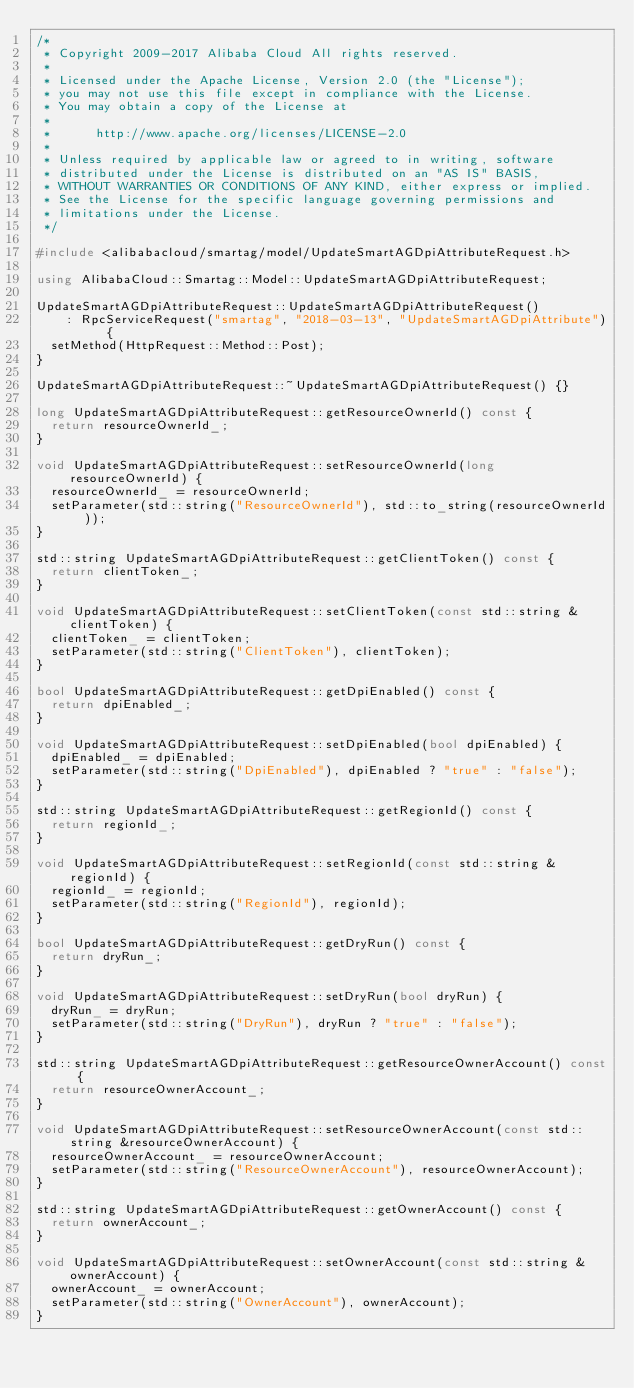Convert code to text. <code><loc_0><loc_0><loc_500><loc_500><_C++_>/*
 * Copyright 2009-2017 Alibaba Cloud All rights reserved.
 *
 * Licensed under the Apache License, Version 2.0 (the "License");
 * you may not use this file except in compliance with the License.
 * You may obtain a copy of the License at
 *
 *      http://www.apache.org/licenses/LICENSE-2.0
 *
 * Unless required by applicable law or agreed to in writing, software
 * distributed under the License is distributed on an "AS IS" BASIS,
 * WITHOUT WARRANTIES OR CONDITIONS OF ANY KIND, either express or implied.
 * See the License for the specific language governing permissions and
 * limitations under the License.
 */

#include <alibabacloud/smartag/model/UpdateSmartAGDpiAttributeRequest.h>

using AlibabaCloud::Smartag::Model::UpdateSmartAGDpiAttributeRequest;

UpdateSmartAGDpiAttributeRequest::UpdateSmartAGDpiAttributeRequest()
    : RpcServiceRequest("smartag", "2018-03-13", "UpdateSmartAGDpiAttribute") {
  setMethod(HttpRequest::Method::Post);
}

UpdateSmartAGDpiAttributeRequest::~UpdateSmartAGDpiAttributeRequest() {}

long UpdateSmartAGDpiAttributeRequest::getResourceOwnerId() const {
  return resourceOwnerId_;
}

void UpdateSmartAGDpiAttributeRequest::setResourceOwnerId(long resourceOwnerId) {
  resourceOwnerId_ = resourceOwnerId;
  setParameter(std::string("ResourceOwnerId"), std::to_string(resourceOwnerId));
}

std::string UpdateSmartAGDpiAttributeRequest::getClientToken() const {
  return clientToken_;
}

void UpdateSmartAGDpiAttributeRequest::setClientToken(const std::string &clientToken) {
  clientToken_ = clientToken;
  setParameter(std::string("ClientToken"), clientToken);
}

bool UpdateSmartAGDpiAttributeRequest::getDpiEnabled() const {
  return dpiEnabled_;
}

void UpdateSmartAGDpiAttributeRequest::setDpiEnabled(bool dpiEnabled) {
  dpiEnabled_ = dpiEnabled;
  setParameter(std::string("DpiEnabled"), dpiEnabled ? "true" : "false");
}

std::string UpdateSmartAGDpiAttributeRequest::getRegionId() const {
  return regionId_;
}

void UpdateSmartAGDpiAttributeRequest::setRegionId(const std::string &regionId) {
  regionId_ = regionId;
  setParameter(std::string("RegionId"), regionId);
}

bool UpdateSmartAGDpiAttributeRequest::getDryRun() const {
  return dryRun_;
}

void UpdateSmartAGDpiAttributeRequest::setDryRun(bool dryRun) {
  dryRun_ = dryRun;
  setParameter(std::string("DryRun"), dryRun ? "true" : "false");
}

std::string UpdateSmartAGDpiAttributeRequest::getResourceOwnerAccount() const {
  return resourceOwnerAccount_;
}

void UpdateSmartAGDpiAttributeRequest::setResourceOwnerAccount(const std::string &resourceOwnerAccount) {
  resourceOwnerAccount_ = resourceOwnerAccount;
  setParameter(std::string("ResourceOwnerAccount"), resourceOwnerAccount);
}

std::string UpdateSmartAGDpiAttributeRequest::getOwnerAccount() const {
  return ownerAccount_;
}

void UpdateSmartAGDpiAttributeRequest::setOwnerAccount(const std::string &ownerAccount) {
  ownerAccount_ = ownerAccount;
  setParameter(std::string("OwnerAccount"), ownerAccount);
}
</code> 